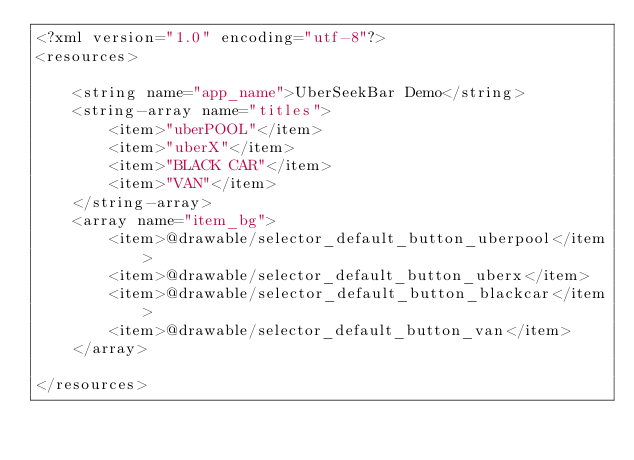<code> <loc_0><loc_0><loc_500><loc_500><_XML_><?xml version="1.0" encoding="utf-8"?>
<resources>

    <string name="app_name">UberSeekBar Demo</string>
    <string-array name="titles">
        <item>"uberPOOL"</item>
        <item>"uberX"</item>
        <item>"BLACK CAR"</item>
        <item>"VAN"</item>
    </string-array>
    <array name="item_bg">
        <item>@drawable/selector_default_button_uberpool</item>
        <item>@drawable/selector_default_button_uberx</item>
        <item>@drawable/selector_default_button_blackcar</item>
        <item>@drawable/selector_default_button_van</item>
    </array>

</resources>
</code> 